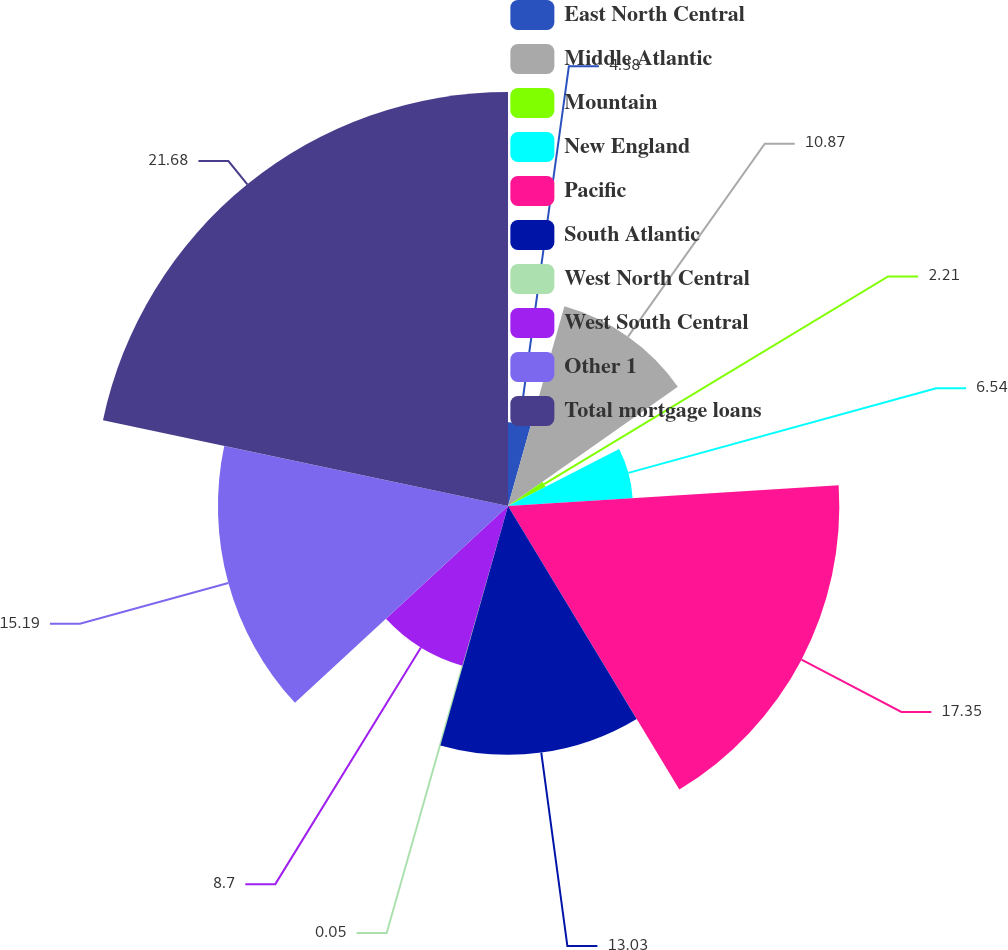<chart> <loc_0><loc_0><loc_500><loc_500><pie_chart><fcel>East North Central<fcel>Middle Atlantic<fcel>Mountain<fcel>New England<fcel>Pacific<fcel>South Atlantic<fcel>West North Central<fcel>West South Central<fcel>Other 1<fcel>Total mortgage loans<nl><fcel>4.38%<fcel>10.87%<fcel>2.21%<fcel>6.54%<fcel>17.35%<fcel>13.03%<fcel>0.05%<fcel>8.7%<fcel>15.19%<fcel>21.68%<nl></chart> 